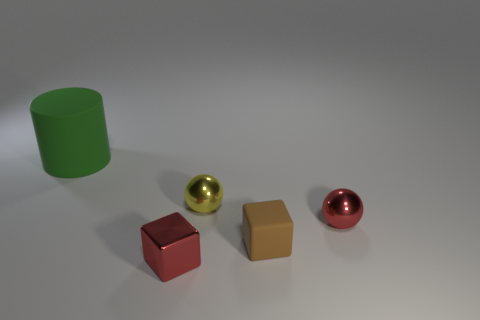Subtract 1 cylinders. How many cylinders are left? 0 Add 3 blue metallic cubes. How many objects exist? 8 Subtract 0 blue balls. How many objects are left? 5 Subtract all blocks. How many objects are left? 3 Subtract all small red things. Subtract all large red objects. How many objects are left? 3 Add 5 metallic blocks. How many metallic blocks are left? 6 Add 2 small blue rubber cylinders. How many small blue rubber cylinders exist? 2 